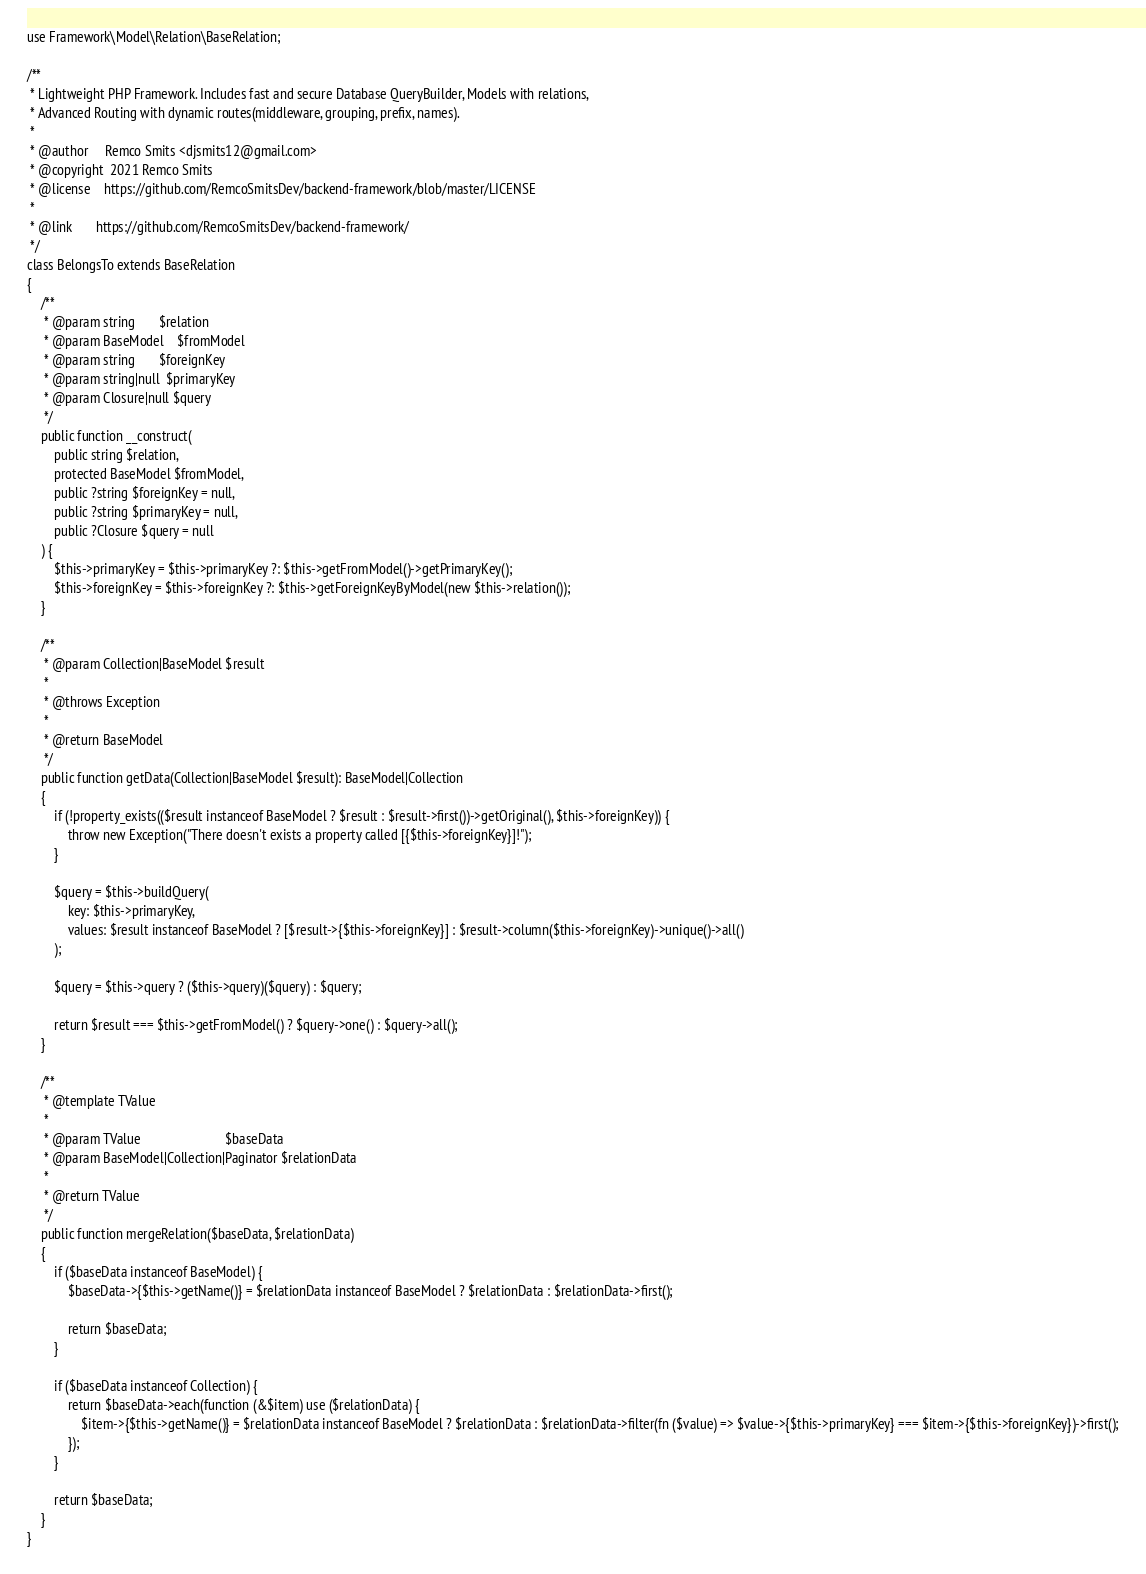Convert code to text. <code><loc_0><loc_0><loc_500><loc_500><_PHP_>use Framework\Model\Relation\BaseRelation;

/**
 * Lightweight PHP Framework. Includes fast and secure Database QueryBuilder, Models with relations,
 * Advanced Routing with dynamic routes(middleware, grouping, prefix, names).
 *
 * @author     Remco Smits <djsmits12@gmail.com>
 * @copyright  2021 Remco Smits
 * @license    https://github.com/RemcoSmitsDev/backend-framework/blob/master/LICENSE
 *
 * @link       https://github.com/RemcoSmitsDev/backend-framework/
 */
class BelongsTo extends BaseRelation
{
    /**
     * @param string       $relation
     * @param BaseModel    $fromModel
     * @param string       $foreignKey
     * @param string|null  $primaryKey
     * @param Closure|null $query
     */
    public function __construct(
        public string $relation,
        protected BaseModel $fromModel,
        public ?string $foreignKey = null,
        public ?string $primaryKey = null,
        public ?Closure $query = null
    ) {
        $this->primaryKey = $this->primaryKey ?: $this->getFromModel()->getPrimaryKey();
        $this->foreignKey = $this->foreignKey ?: $this->getForeignKeyByModel(new $this->relation());
    }

    /**
     * @param Collection|BaseModel $result
     *
     * @throws Exception
     *
     * @return BaseModel
     */
    public function getData(Collection|BaseModel $result): BaseModel|Collection
    {
        if (!property_exists(($result instanceof BaseModel ? $result : $result->first())->getOriginal(), $this->foreignKey)) {
            throw new Exception("There doesn't exists a property called [{$this->foreignKey}]!");
        }

        $query = $this->buildQuery(
            key: $this->primaryKey,
            values: $result instanceof BaseModel ? [$result->{$this->foreignKey}] : $result->column($this->foreignKey)->unique()->all()
        );

        $query = $this->query ? ($this->query)($query) : $query;

        return $result === $this->getFromModel() ? $query->one() : $query->all();
    }

    /**
     * @template TValue
     *
     * @param TValue                         $baseData
     * @param BaseModel|Collection|Paginator $relationData
     *
     * @return TValue
     */
    public function mergeRelation($baseData, $relationData)
    {
        if ($baseData instanceof BaseModel) {
            $baseData->{$this->getName()} = $relationData instanceof BaseModel ? $relationData : $relationData->first();

            return $baseData;
        }

        if ($baseData instanceof Collection) {
            return $baseData->each(function (&$item) use ($relationData) {
                $item->{$this->getName()} = $relationData instanceof BaseModel ? $relationData : $relationData->filter(fn ($value) => $value->{$this->primaryKey} === $item->{$this->foreignKey})->first();
            });
        }

        return $baseData;
    }
}
</code> 